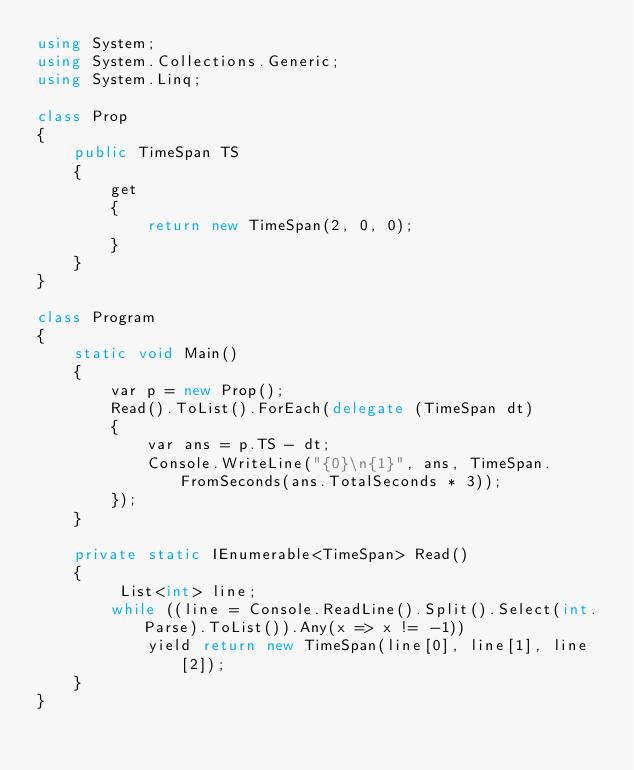<code> <loc_0><loc_0><loc_500><loc_500><_C#_>using System;
using System.Collections.Generic;
using System.Linq;

class Prop
{
    public TimeSpan TS
    {
        get
        {
            return new TimeSpan(2, 0, 0);
        }
    }
}

class Program
{
    static void Main()
    {
        var p = new Prop();
        Read().ToList().ForEach(delegate (TimeSpan dt)
        {
            var ans = p.TS - dt;
            Console.WriteLine("{0}\n{1}", ans, TimeSpan.FromSeconds(ans.TotalSeconds * 3));
        });
    }

    private static IEnumerable<TimeSpan> Read()
    {
         List<int> line;
        while ((line = Console.ReadLine().Split().Select(int.Parse).ToList()).Any(x => x != -1))
            yield return new TimeSpan(line[0], line[1], line[2]);
    }
}
</code> 